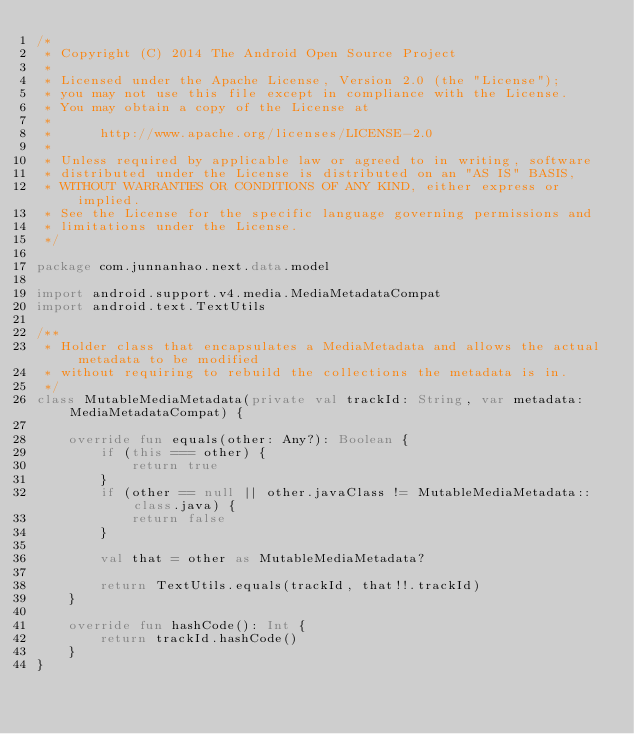<code> <loc_0><loc_0><loc_500><loc_500><_Kotlin_>/*
 * Copyright (C) 2014 The Android Open Source Project
 *
 * Licensed under the Apache License, Version 2.0 (the "License");
 * you may not use this file except in compliance with the License.
 * You may obtain a copy of the License at
 *
 *      http://www.apache.org/licenses/LICENSE-2.0
 *
 * Unless required by applicable law or agreed to in writing, software
 * distributed under the License is distributed on an "AS IS" BASIS,
 * WITHOUT WARRANTIES OR CONDITIONS OF ANY KIND, either express or implied.
 * See the License for the specific language governing permissions and
 * limitations under the License.
 */

package com.junnanhao.next.data.model

import android.support.v4.media.MediaMetadataCompat
import android.text.TextUtils

/**
 * Holder class that encapsulates a MediaMetadata and allows the actual metadata to be modified
 * without requiring to rebuild the collections the metadata is in.
 */
class MutableMediaMetadata(private val trackId: String, var metadata: MediaMetadataCompat) {

    override fun equals(other: Any?): Boolean {
        if (this === other) {
            return true
        }
        if (other == null || other.javaClass != MutableMediaMetadata::class.java) {
            return false
        }

        val that = other as MutableMediaMetadata?

        return TextUtils.equals(trackId, that!!.trackId)
    }

    override fun hashCode(): Int {
        return trackId.hashCode()
    }
}
</code> 